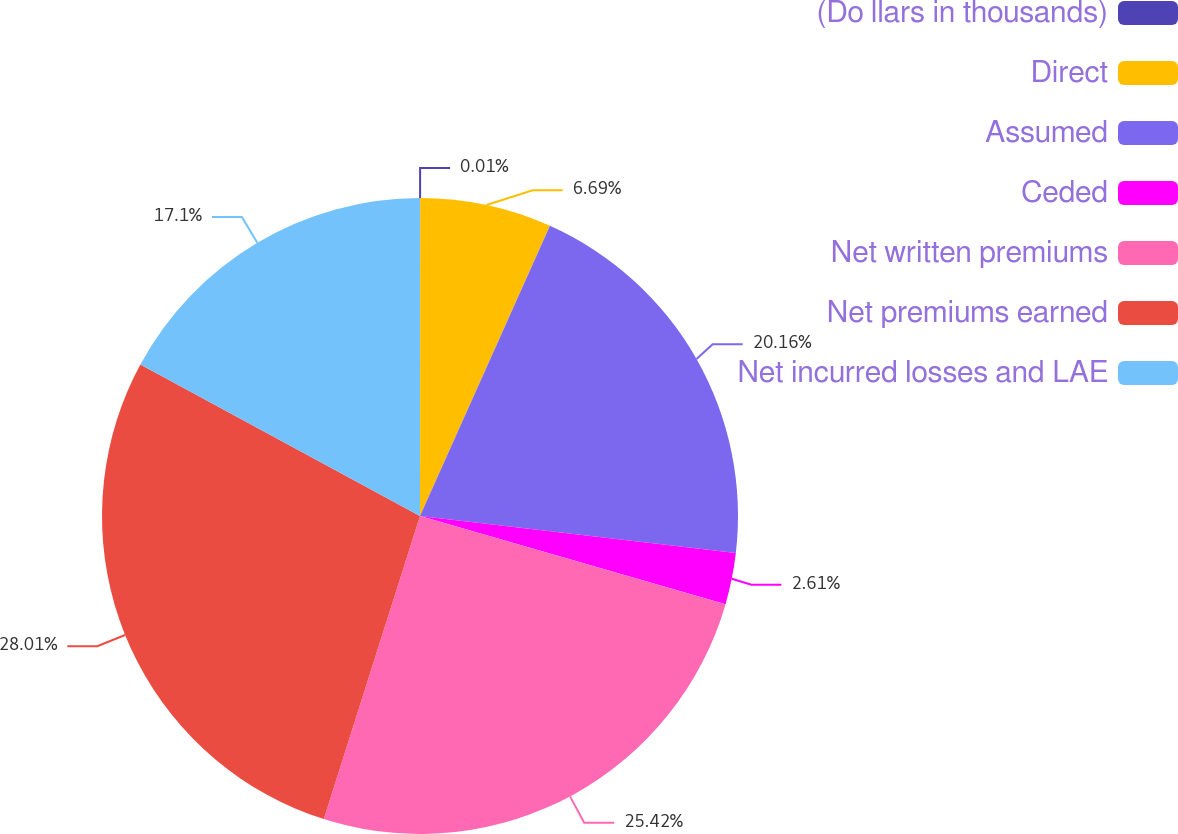Convert chart. <chart><loc_0><loc_0><loc_500><loc_500><pie_chart><fcel>(Do llars in thousands)<fcel>Direct<fcel>Assumed<fcel>Ceded<fcel>Net written premiums<fcel>Net premiums earned<fcel>Net incurred losses and LAE<nl><fcel>0.01%<fcel>6.69%<fcel>20.16%<fcel>2.61%<fcel>25.42%<fcel>28.01%<fcel>17.1%<nl></chart> 